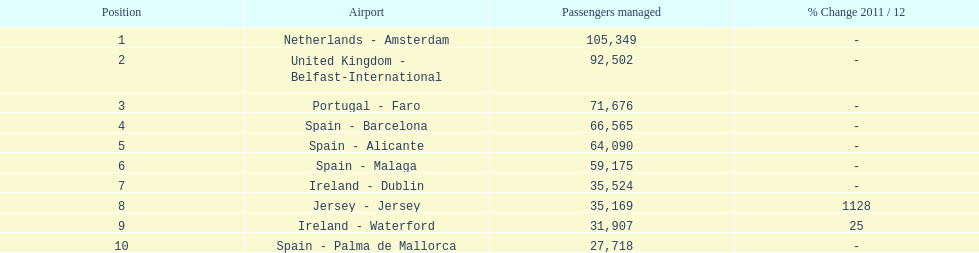How many airports are listed? 10. 